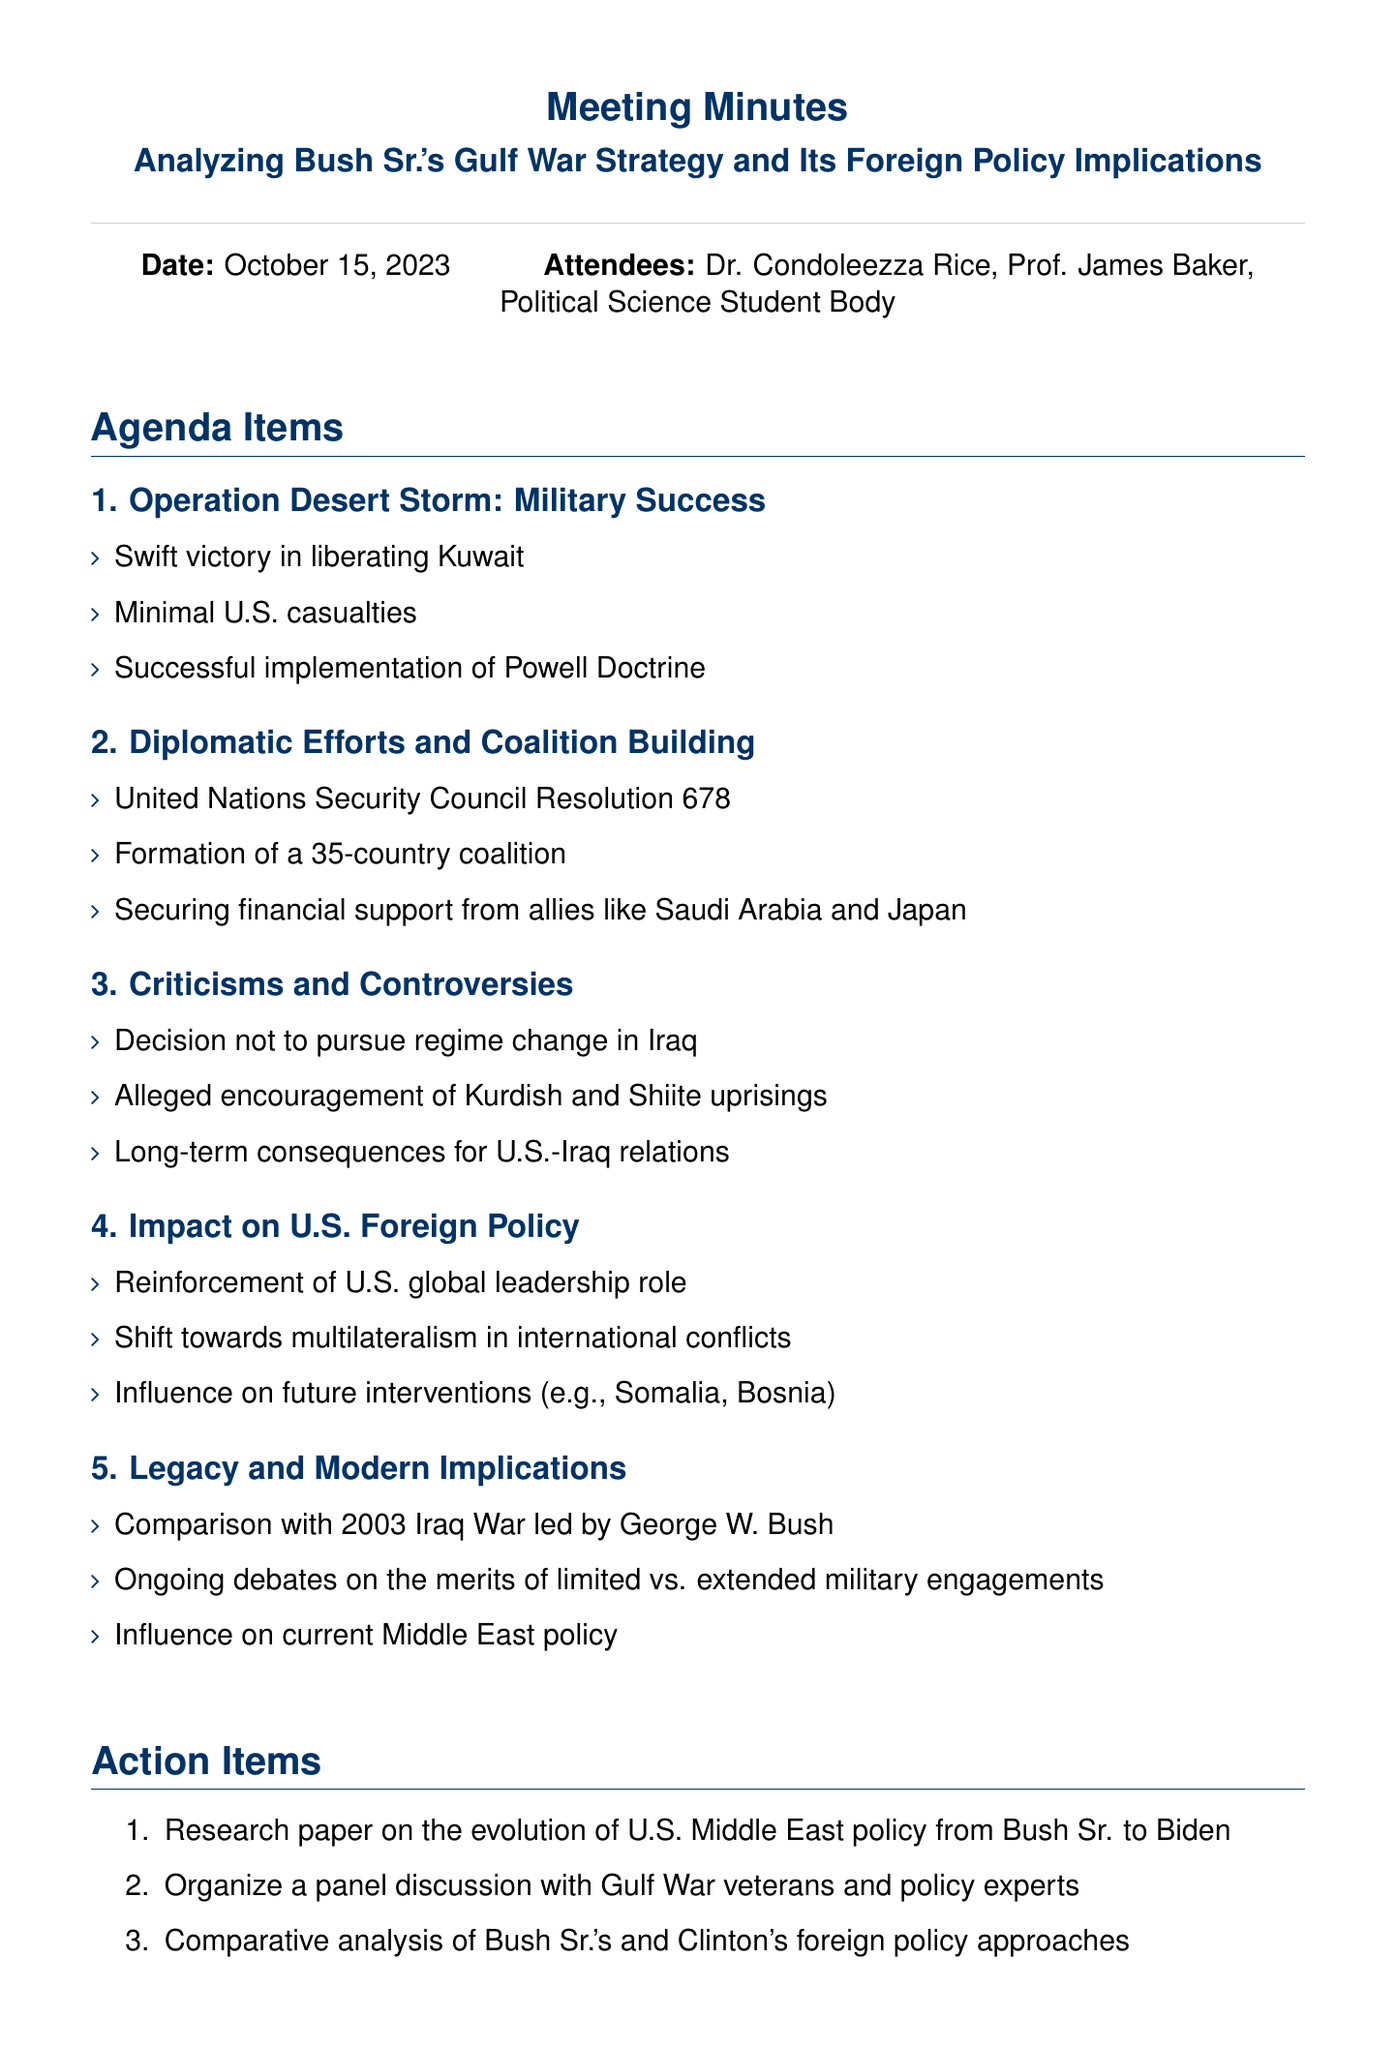What was the date of the meeting? The date of the meeting is explicitly mentioned in the document.
Answer: October 15, 2023 Who was the guest speaker at the meeting? The guest speaker is listed as one of the attendees in the document.
Answer: Dr. Condoleezza Rice What operation is discussed as a military success? This information is included in the "Operation Desert Storm: Military Success" section of the document.
Answer: Operation Desert Storm How many countries formed the coalition during the Gulf War? This number is provided in the "Diplomatic Efforts and Coalition Building" section of the agenda items.
Answer: 35 What was one criticism of Bush Sr.'s Gulf War strategy? Criticisms are outlined under the "Criticisms and Controversies" section.
Answer: Decision not to pursue regime change in Iraq What shift in U.S. foreign policy is mentioned as a result of the Gulf War? This shift is discussed in the "Impact on U.S. Foreign Policy" section.
Answer: Shift towards multilateralism Which two U.S. presidents' foreign policies are compared in the legacy section? This comparison is stated in the “Legacy and Modern Implications” agenda item.
Answer: Bush Sr. and Clinton What is one action item listed for the student body? The action items section lists tasks to be completed by the attendees.
Answer: Research paper on the evolution of U.S. Middle East policy from Bush Sr. to Biden 